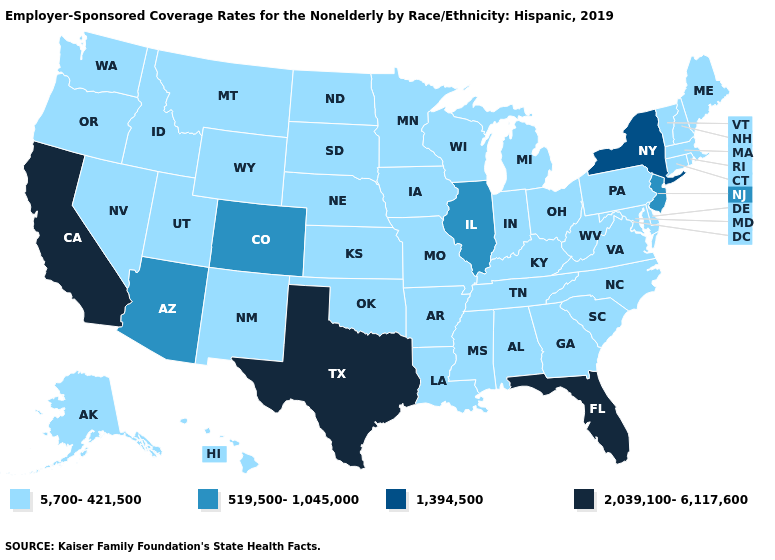Does Arkansas have the highest value in the USA?
Short answer required. No. What is the lowest value in the USA?
Keep it brief. 5,700-421,500. Which states have the lowest value in the USA?
Write a very short answer. Alabama, Alaska, Arkansas, Connecticut, Delaware, Georgia, Hawaii, Idaho, Indiana, Iowa, Kansas, Kentucky, Louisiana, Maine, Maryland, Massachusetts, Michigan, Minnesota, Mississippi, Missouri, Montana, Nebraska, Nevada, New Hampshire, New Mexico, North Carolina, North Dakota, Ohio, Oklahoma, Oregon, Pennsylvania, Rhode Island, South Carolina, South Dakota, Tennessee, Utah, Vermont, Virginia, Washington, West Virginia, Wisconsin, Wyoming. What is the value of Connecticut?
Be succinct. 5,700-421,500. Name the states that have a value in the range 5,700-421,500?
Short answer required. Alabama, Alaska, Arkansas, Connecticut, Delaware, Georgia, Hawaii, Idaho, Indiana, Iowa, Kansas, Kentucky, Louisiana, Maine, Maryland, Massachusetts, Michigan, Minnesota, Mississippi, Missouri, Montana, Nebraska, Nevada, New Hampshire, New Mexico, North Carolina, North Dakota, Ohio, Oklahoma, Oregon, Pennsylvania, Rhode Island, South Carolina, South Dakota, Tennessee, Utah, Vermont, Virginia, Washington, West Virginia, Wisconsin, Wyoming. What is the value of South Dakota?
Quick response, please. 5,700-421,500. Does New York have the highest value in the Northeast?
Answer briefly. Yes. What is the value of New Hampshire?
Be succinct. 5,700-421,500. What is the highest value in states that border Pennsylvania?
Concise answer only. 1,394,500. Does Vermont have the lowest value in the USA?
Give a very brief answer. Yes. Does the first symbol in the legend represent the smallest category?
Keep it brief. Yes. Among the states that border Virginia , which have the highest value?
Write a very short answer. Kentucky, Maryland, North Carolina, Tennessee, West Virginia. Name the states that have a value in the range 519,500-1,045,000?
Keep it brief. Arizona, Colorado, Illinois, New Jersey. Is the legend a continuous bar?
Keep it brief. No. Name the states that have a value in the range 5,700-421,500?
Concise answer only. Alabama, Alaska, Arkansas, Connecticut, Delaware, Georgia, Hawaii, Idaho, Indiana, Iowa, Kansas, Kentucky, Louisiana, Maine, Maryland, Massachusetts, Michigan, Minnesota, Mississippi, Missouri, Montana, Nebraska, Nevada, New Hampshire, New Mexico, North Carolina, North Dakota, Ohio, Oklahoma, Oregon, Pennsylvania, Rhode Island, South Carolina, South Dakota, Tennessee, Utah, Vermont, Virginia, Washington, West Virginia, Wisconsin, Wyoming. 